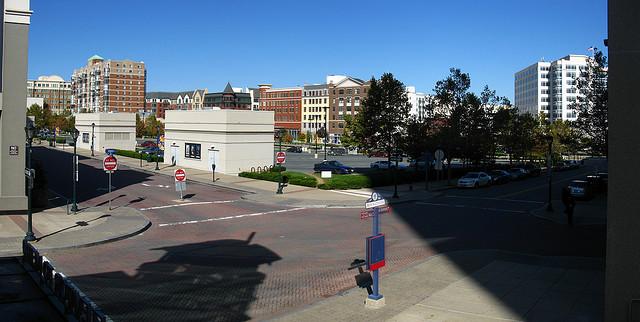Are there any cars on the road?
Short answer required. No. How is the weather in the picture?
Give a very brief answer. Sunny. Are there cars parked?
Keep it brief. Yes. 